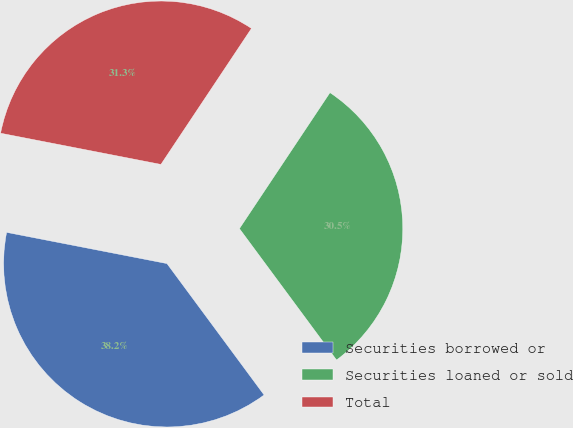Convert chart. <chart><loc_0><loc_0><loc_500><loc_500><pie_chart><fcel>Securities borrowed or<fcel>Securities loaned or sold<fcel>Total<nl><fcel>38.19%<fcel>30.52%<fcel>31.29%<nl></chart> 